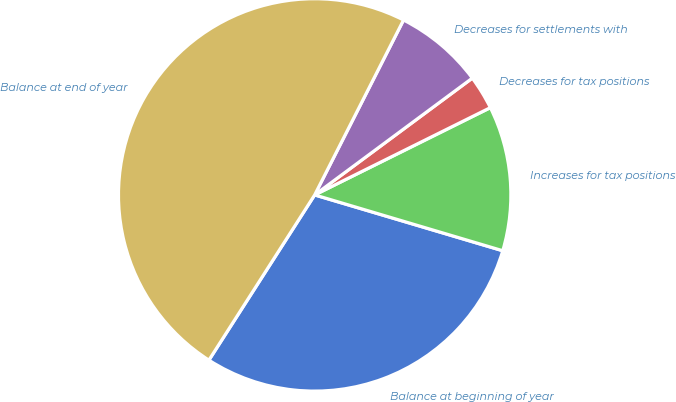Convert chart. <chart><loc_0><loc_0><loc_500><loc_500><pie_chart><fcel>Balance at beginning of year<fcel>Increases for tax positions<fcel>Decreases for tax positions<fcel>Decreases for settlements with<fcel>Balance at end of year<nl><fcel>29.47%<fcel>11.93%<fcel>2.81%<fcel>7.37%<fcel>48.42%<nl></chart> 